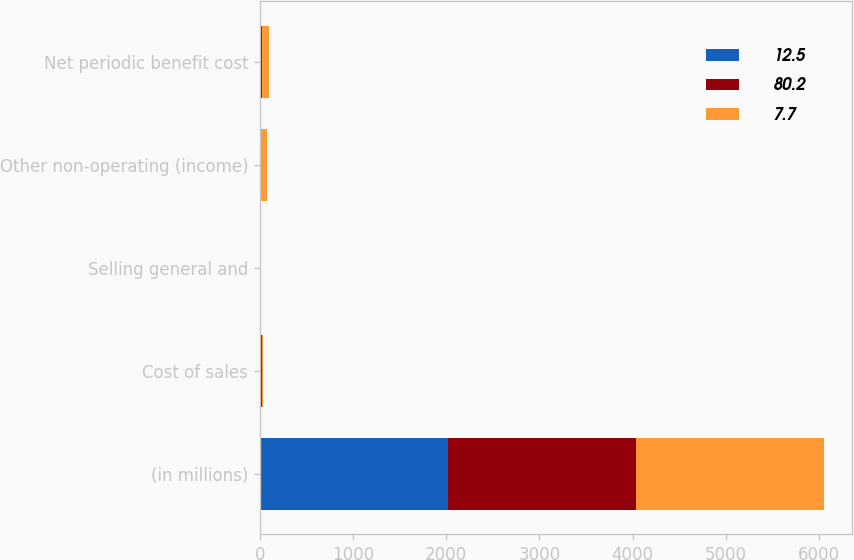<chart> <loc_0><loc_0><loc_500><loc_500><stacked_bar_chart><ecel><fcel>(in millions)<fcel>Cost of sales<fcel>Selling general and<fcel>Other non-operating (income)<fcel>Net periodic benefit cost<nl><fcel>12.5<fcel>2019<fcel>10.3<fcel>4.6<fcel>2.4<fcel>12.5<nl><fcel>80.2<fcel>2018<fcel>11.3<fcel>5<fcel>8.6<fcel>7.7<nl><fcel>7.7<fcel>2017<fcel>12.1<fcel>5.8<fcel>62.3<fcel>80.2<nl></chart> 